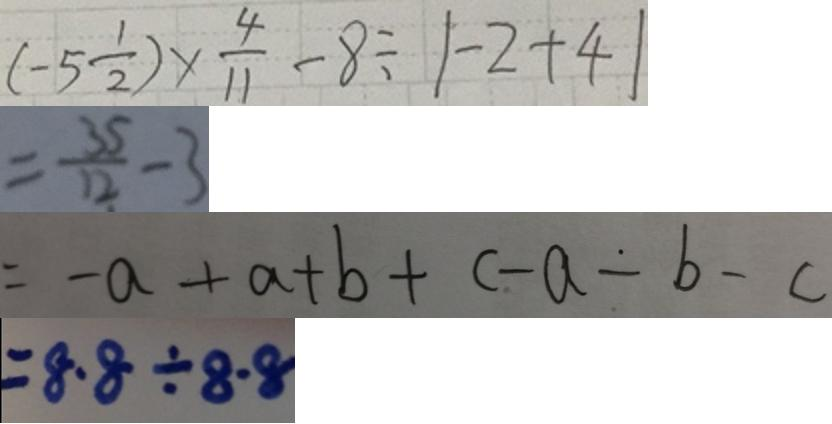Convert formula to latex. <formula><loc_0><loc_0><loc_500><loc_500>( - 5 \frac { 1 } { 2 } ) \times \frac { 4 } { 1 1 } - 8 \div \vert - 2 + 4 \vert 
 = \frac { 3 5 } { 1 2 } - 3 
 = - a + a + b + c - a - b - c 
 = 8 . 8 \div 8 . 8</formula> 